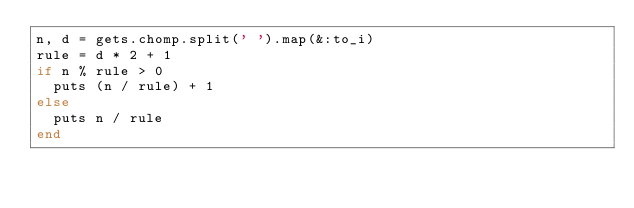<code> <loc_0><loc_0><loc_500><loc_500><_Ruby_>n, d = gets.chomp.split(' ').map(&:to_i)
rule = d * 2 + 1
if n % rule > 0
  puts (n / rule) + 1
else
  puts n / rule
end
</code> 